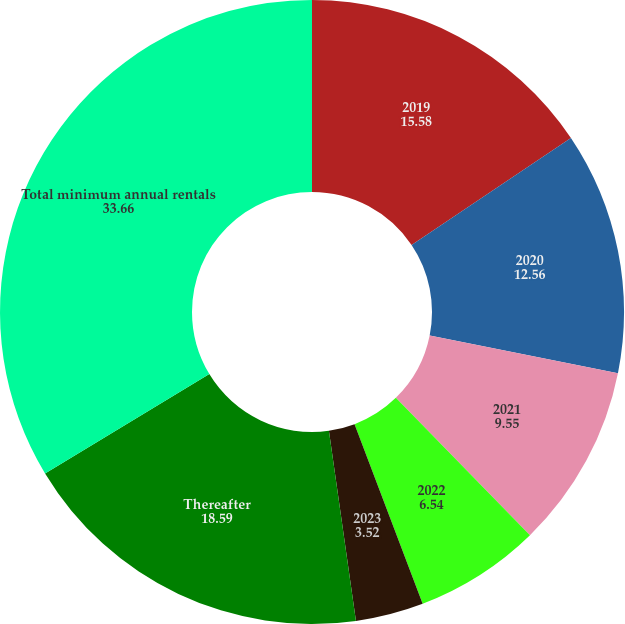<chart> <loc_0><loc_0><loc_500><loc_500><pie_chart><fcel>2019<fcel>2020<fcel>2021<fcel>2022<fcel>2023<fcel>Thereafter<fcel>Total minimum annual rentals<nl><fcel>15.58%<fcel>12.56%<fcel>9.55%<fcel>6.54%<fcel>3.52%<fcel>18.59%<fcel>33.66%<nl></chart> 